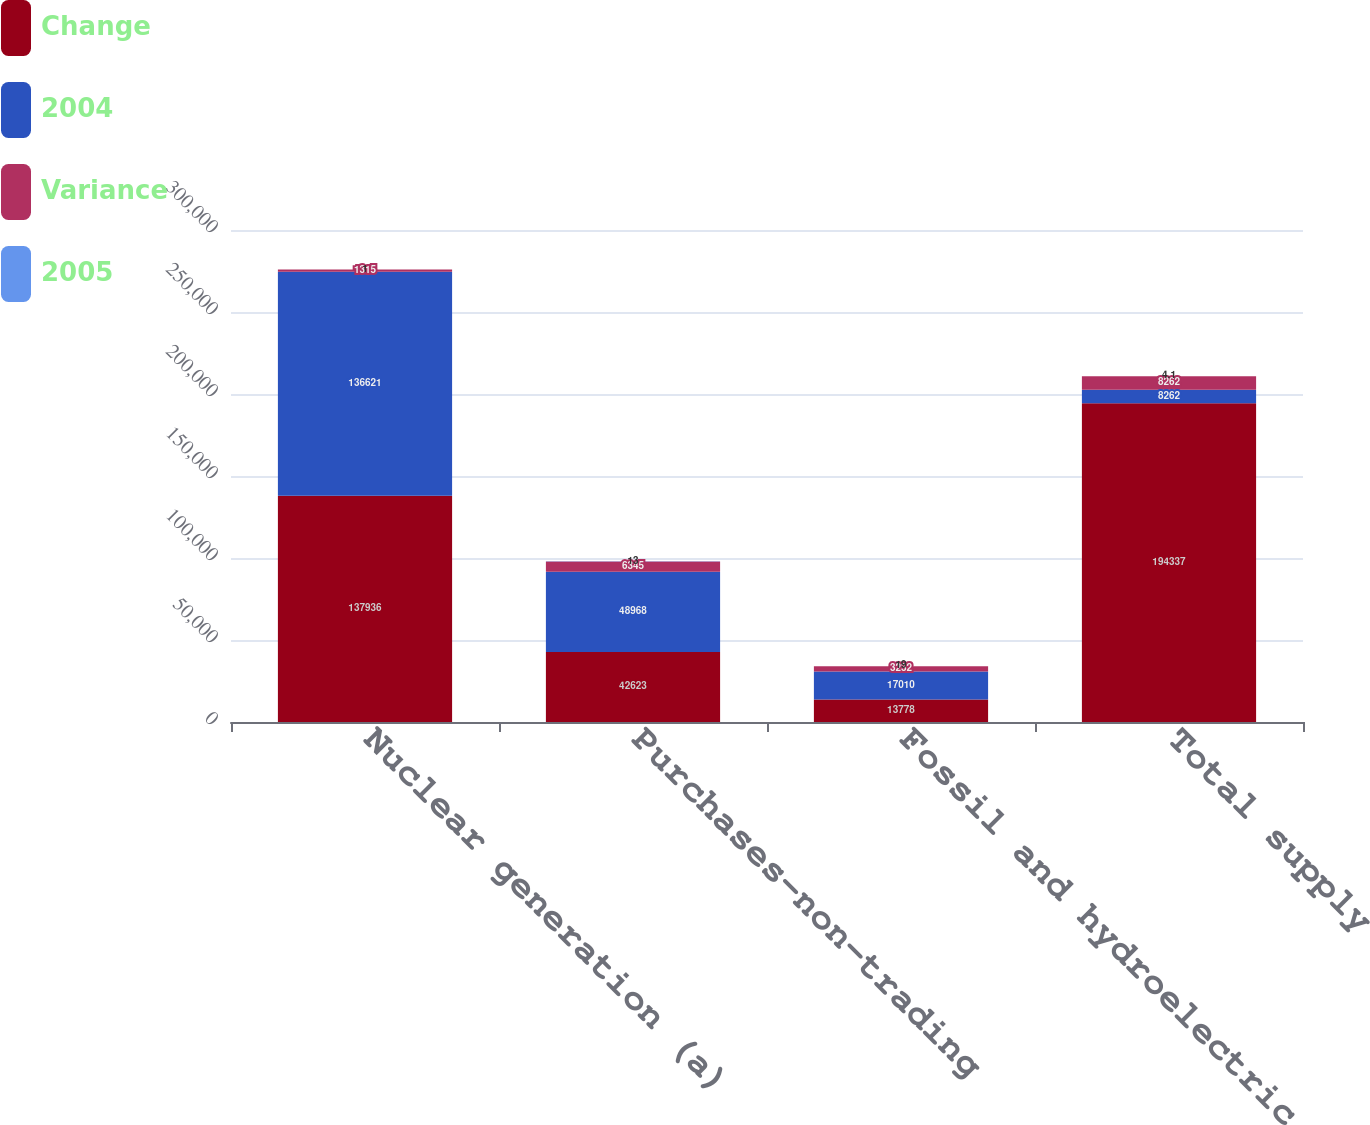<chart> <loc_0><loc_0><loc_500><loc_500><stacked_bar_chart><ecel><fcel>Nuclear generation (a)<fcel>Purchases-non-trading<fcel>Fossil and hydroelectric<fcel>Total supply<nl><fcel>Change<fcel>137936<fcel>42623<fcel>13778<fcel>194337<nl><fcel>2004<fcel>136621<fcel>48968<fcel>17010<fcel>8262<nl><fcel>Variance<fcel>1315<fcel>6345<fcel>3232<fcel>8262<nl><fcel>2005<fcel>1<fcel>13<fcel>19<fcel>4.1<nl></chart> 